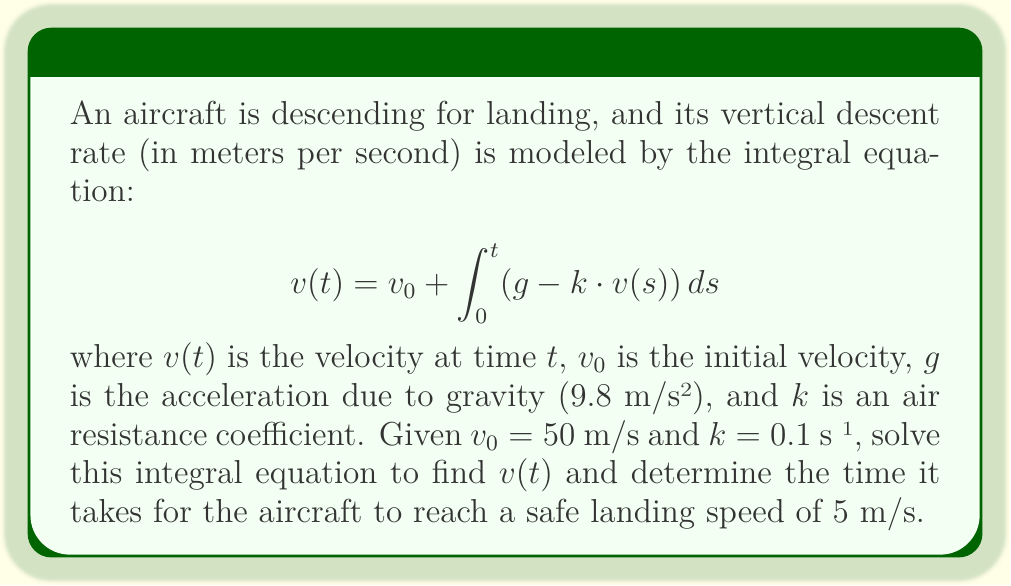Provide a solution to this math problem. To solve this integral equation, we'll follow these steps:

1) First, we recognize this as a linear integral equation of the second kind. We can solve it by differentiating both sides with respect to $t$:

   $$\frac{d}{dt}v(t) = \frac{d}{dt}v_0 + \frac{d}{dt}\int_0^t (g - k \cdot v(s)) ds$$

2) Using the Fundamental Theorem of Calculus, this simplifies to:

   $$\frac{dv}{dt} = g - k \cdot v(t)$$

3) This is now a first-order linear differential equation. We can solve it using the integrating factor method. The integrating factor is $e^{kt}$:

   $$\frac{d}{dt}(v \cdot e^{kt}) = g \cdot e^{kt}$$

4) Integrating both sides:

   $$v \cdot e^{kt} = \frac{g}{k} \cdot e^{kt} + C$$

5) Solving for $v(t)$:

   $$v(t) = \frac{g}{k} + C \cdot e^{-kt}$$

6) Using the initial condition $v(0) = v_0 = 50$, we can find $C$:

   $$50 = \frac{9.8}{0.1} + C \implies C = 50 - 98 = -48$$

7) Therefore, the solution is:

   $$v(t) = 98 - 48e^{-0.1t}$$

8) To find when the aircraft reaches 5 m/s, we solve:

   $$5 = 98 - 48e^{-0.1t}$$
   $$48e^{-0.1t} = 93$$
   $$e^{-0.1t} = \frac{93}{48}$$
   $$-0.1t = \ln(\frac{93}{48})$$
   $$t = -10 \ln(\frac{93}{48}) \approx 6.63 \text{ seconds}$$
Answer: $v(t) = 98 - 48e^{-0.1t}$; Time to reach 5 m/s: 6.63 seconds 